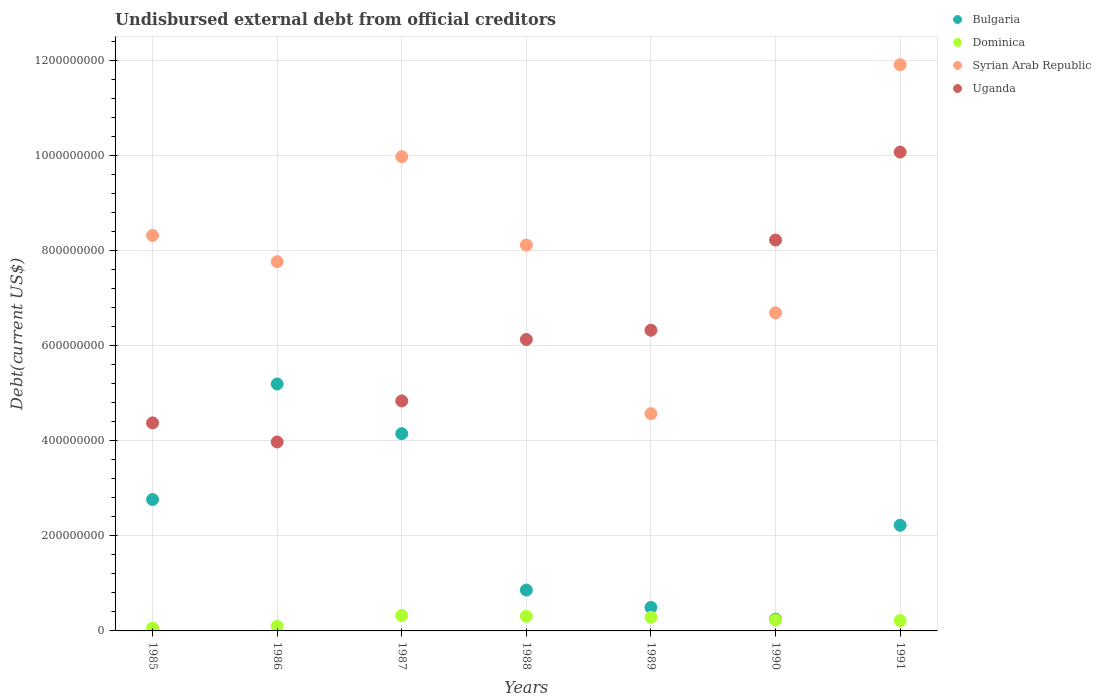What is the total debt in Syrian Arab Republic in 1987?
Your answer should be very brief. 9.97e+08. Across all years, what is the maximum total debt in Syrian Arab Republic?
Provide a succinct answer. 1.19e+09. Across all years, what is the minimum total debt in Bulgaria?
Your answer should be compact. 2.48e+07. In which year was the total debt in Uganda maximum?
Your answer should be very brief. 1991. In which year was the total debt in Bulgaria minimum?
Keep it short and to the point. 1990. What is the total total debt in Bulgaria in the graph?
Keep it short and to the point. 1.59e+09. What is the difference between the total debt in Dominica in 1985 and that in 1987?
Your answer should be compact. -2.63e+07. What is the difference between the total debt in Dominica in 1985 and the total debt in Syrian Arab Republic in 1986?
Offer a terse response. -7.70e+08. What is the average total debt in Uganda per year?
Your answer should be very brief. 6.27e+08. In the year 1985, what is the difference between the total debt in Syrian Arab Republic and total debt in Uganda?
Give a very brief answer. 3.94e+08. In how many years, is the total debt in Dominica greater than 720000000 US$?
Offer a very short reply. 0. What is the ratio of the total debt in Dominica in 1987 to that in 1990?
Your answer should be compact. 1.41. Is the total debt in Syrian Arab Republic in 1987 less than that in 1990?
Your answer should be very brief. No. What is the difference between the highest and the second highest total debt in Dominica?
Provide a succinct answer. 1.74e+06. What is the difference between the highest and the lowest total debt in Uganda?
Ensure brevity in your answer.  6.09e+08. Is the sum of the total debt in Bulgaria in 1986 and 1987 greater than the maximum total debt in Dominica across all years?
Offer a terse response. Yes. Is it the case that in every year, the sum of the total debt in Bulgaria and total debt in Syrian Arab Republic  is greater than the sum of total debt in Uganda and total debt in Dominica?
Your answer should be very brief. No. Is the total debt in Syrian Arab Republic strictly greater than the total debt in Dominica over the years?
Ensure brevity in your answer.  Yes. Is the total debt in Bulgaria strictly less than the total debt in Syrian Arab Republic over the years?
Offer a very short reply. Yes. What is the difference between two consecutive major ticks on the Y-axis?
Make the answer very short. 2.00e+08. Where does the legend appear in the graph?
Your answer should be compact. Top right. What is the title of the graph?
Keep it short and to the point. Undisbursed external debt from official creditors. Does "Brunei Darussalam" appear as one of the legend labels in the graph?
Provide a succinct answer. No. What is the label or title of the X-axis?
Your answer should be very brief. Years. What is the label or title of the Y-axis?
Your response must be concise. Debt(current US$). What is the Debt(current US$) in Bulgaria in 1985?
Your response must be concise. 2.76e+08. What is the Debt(current US$) in Dominica in 1985?
Your answer should be very brief. 6.17e+06. What is the Debt(current US$) of Syrian Arab Republic in 1985?
Offer a very short reply. 8.31e+08. What is the Debt(current US$) of Uganda in 1985?
Make the answer very short. 4.37e+08. What is the Debt(current US$) of Bulgaria in 1986?
Ensure brevity in your answer.  5.19e+08. What is the Debt(current US$) in Dominica in 1986?
Provide a succinct answer. 9.94e+06. What is the Debt(current US$) in Syrian Arab Republic in 1986?
Make the answer very short. 7.76e+08. What is the Debt(current US$) of Uganda in 1986?
Your answer should be very brief. 3.97e+08. What is the Debt(current US$) in Bulgaria in 1987?
Provide a short and direct response. 4.15e+08. What is the Debt(current US$) of Dominica in 1987?
Your answer should be compact. 3.25e+07. What is the Debt(current US$) of Syrian Arab Republic in 1987?
Keep it short and to the point. 9.97e+08. What is the Debt(current US$) in Uganda in 1987?
Keep it short and to the point. 4.83e+08. What is the Debt(current US$) in Bulgaria in 1988?
Make the answer very short. 8.59e+07. What is the Debt(current US$) in Dominica in 1988?
Offer a terse response. 3.07e+07. What is the Debt(current US$) of Syrian Arab Republic in 1988?
Give a very brief answer. 8.11e+08. What is the Debt(current US$) of Uganda in 1988?
Your answer should be compact. 6.13e+08. What is the Debt(current US$) in Bulgaria in 1989?
Ensure brevity in your answer.  4.94e+07. What is the Debt(current US$) of Dominica in 1989?
Your response must be concise. 2.86e+07. What is the Debt(current US$) of Syrian Arab Republic in 1989?
Offer a terse response. 4.57e+08. What is the Debt(current US$) of Uganda in 1989?
Keep it short and to the point. 6.32e+08. What is the Debt(current US$) of Bulgaria in 1990?
Offer a very short reply. 2.48e+07. What is the Debt(current US$) in Dominica in 1990?
Ensure brevity in your answer.  2.30e+07. What is the Debt(current US$) in Syrian Arab Republic in 1990?
Keep it short and to the point. 6.69e+08. What is the Debt(current US$) in Uganda in 1990?
Offer a very short reply. 8.22e+08. What is the Debt(current US$) in Bulgaria in 1991?
Your answer should be very brief. 2.22e+08. What is the Debt(current US$) of Dominica in 1991?
Ensure brevity in your answer.  2.18e+07. What is the Debt(current US$) in Syrian Arab Republic in 1991?
Your response must be concise. 1.19e+09. What is the Debt(current US$) in Uganda in 1991?
Make the answer very short. 1.01e+09. Across all years, what is the maximum Debt(current US$) in Bulgaria?
Keep it short and to the point. 5.19e+08. Across all years, what is the maximum Debt(current US$) in Dominica?
Your response must be concise. 3.25e+07. Across all years, what is the maximum Debt(current US$) in Syrian Arab Republic?
Your response must be concise. 1.19e+09. Across all years, what is the maximum Debt(current US$) in Uganda?
Your answer should be very brief. 1.01e+09. Across all years, what is the minimum Debt(current US$) in Bulgaria?
Provide a short and direct response. 2.48e+07. Across all years, what is the minimum Debt(current US$) of Dominica?
Your response must be concise. 6.17e+06. Across all years, what is the minimum Debt(current US$) of Syrian Arab Republic?
Make the answer very short. 4.57e+08. Across all years, what is the minimum Debt(current US$) in Uganda?
Ensure brevity in your answer.  3.97e+08. What is the total Debt(current US$) of Bulgaria in the graph?
Your answer should be compact. 1.59e+09. What is the total Debt(current US$) of Dominica in the graph?
Keep it short and to the point. 1.53e+08. What is the total Debt(current US$) in Syrian Arab Republic in the graph?
Your answer should be compact. 5.73e+09. What is the total Debt(current US$) of Uganda in the graph?
Your answer should be compact. 4.39e+09. What is the difference between the Debt(current US$) in Bulgaria in 1985 and that in 1986?
Offer a terse response. -2.43e+08. What is the difference between the Debt(current US$) in Dominica in 1985 and that in 1986?
Your answer should be compact. -3.77e+06. What is the difference between the Debt(current US$) in Syrian Arab Republic in 1985 and that in 1986?
Ensure brevity in your answer.  5.51e+07. What is the difference between the Debt(current US$) in Uganda in 1985 and that in 1986?
Give a very brief answer. 4.01e+07. What is the difference between the Debt(current US$) in Bulgaria in 1985 and that in 1987?
Make the answer very short. -1.38e+08. What is the difference between the Debt(current US$) in Dominica in 1985 and that in 1987?
Offer a terse response. -2.63e+07. What is the difference between the Debt(current US$) of Syrian Arab Republic in 1985 and that in 1987?
Keep it short and to the point. -1.66e+08. What is the difference between the Debt(current US$) of Uganda in 1985 and that in 1987?
Make the answer very short. -4.61e+07. What is the difference between the Debt(current US$) in Bulgaria in 1985 and that in 1988?
Make the answer very short. 1.90e+08. What is the difference between the Debt(current US$) in Dominica in 1985 and that in 1988?
Provide a short and direct response. -2.46e+07. What is the difference between the Debt(current US$) in Syrian Arab Republic in 1985 and that in 1988?
Ensure brevity in your answer.  2.02e+07. What is the difference between the Debt(current US$) of Uganda in 1985 and that in 1988?
Provide a short and direct response. -1.75e+08. What is the difference between the Debt(current US$) of Bulgaria in 1985 and that in 1989?
Provide a succinct answer. 2.27e+08. What is the difference between the Debt(current US$) in Dominica in 1985 and that in 1989?
Your answer should be very brief. -2.24e+07. What is the difference between the Debt(current US$) in Syrian Arab Republic in 1985 and that in 1989?
Your answer should be compact. 3.75e+08. What is the difference between the Debt(current US$) in Uganda in 1985 and that in 1989?
Your answer should be very brief. -1.95e+08. What is the difference between the Debt(current US$) in Bulgaria in 1985 and that in 1990?
Your answer should be compact. 2.51e+08. What is the difference between the Debt(current US$) in Dominica in 1985 and that in 1990?
Your answer should be very brief. -1.68e+07. What is the difference between the Debt(current US$) in Syrian Arab Republic in 1985 and that in 1990?
Offer a very short reply. 1.62e+08. What is the difference between the Debt(current US$) in Uganda in 1985 and that in 1990?
Offer a very short reply. -3.84e+08. What is the difference between the Debt(current US$) in Bulgaria in 1985 and that in 1991?
Give a very brief answer. 5.41e+07. What is the difference between the Debt(current US$) in Dominica in 1985 and that in 1991?
Your response must be concise. -1.56e+07. What is the difference between the Debt(current US$) in Syrian Arab Republic in 1985 and that in 1991?
Offer a terse response. -3.59e+08. What is the difference between the Debt(current US$) of Uganda in 1985 and that in 1991?
Your answer should be very brief. -5.69e+08. What is the difference between the Debt(current US$) of Bulgaria in 1986 and that in 1987?
Provide a succinct answer. 1.04e+08. What is the difference between the Debt(current US$) in Dominica in 1986 and that in 1987?
Ensure brevity in your answer.  -2.25e+07. What is the difference between the Debt(current US$) of Syrian Arab Republic in 1986 and that in 1987?
Offer a very short reply. -2.21e+08. What is the difference between the Debt(current US$) of Uganda in 1986 and that in 1987?
Give a very brief answer. -8.62e+07. What is the difference between the Debt(current US$) of Bulgaria in 1986 and that in 1988?
Give a very brief answer. 4.33e+08. What is the difference between the Debt(current US$) of Dominica in 1986 and that in 1988?
Offer a terse response. -2.08e+07. What is the difference between the Debt(current US$) in Syrian Arab Republic in 1986 and that in 1988?
Keep it short and to the point. -3.49e+07. What is the difference between the Debt(current US$) of Uganda in 1986 and that in 1988?
Provide a succinct answer. -2.15e+08. What is the difference between the Debt(current US$) in Bulgaria in 1986 and that in 1989?
Provide a short and direct response. 4.70e+08. What is the difference between the Debt(current US$) in Dominica in 1986 and that in 1989?
Provide a short and direct response. -1.86e+07. What is the difference between the Debt(current US$) in Syrian Arab Republic in 1986 and that in 1989?
Make the answer very short. 3.20e+08. What is the difference between the Debt(current US$) of Uganda in 1986 and that in 1989?
Give a very brief answer. -2.35e+08. What is the difference between the Debt(current US$) in Bulgaria in 1986 and that in 1990?
Offer a terse response. 4.94e+08. What is the difference between the Debt(current US$) in Dominica in 1986 and that in 1990?
Offer a very short reply. -1.30e+07. What is the difference between the Debt(current US$) in Syrian Arab Republic in 1986 and that in 1990?
Provide a short and direct response. 1.07e+08. What is the difference between the Debt(current US$) of Uganda in 1986 and that in 1990?
Ensure brevity in your answer.  -4.24e+08. What is the difference between the Debt(current US$) of Bulgaria in 1986 and that in 1991?
Give a very brief answer. 2.97e+08. What is the difference between the Debt(current US$) in Dominica in 1986 and that in 1991?
Keep it short and to the point. -1.18e+07. What is the difference between the Debt(current US$) of Syrian Arab Republic in 1986 and that in 1991?
Your response must be concise. -4.14e+08. What is the difference between the Debt(current US$) in Uganda in 1986 and that in 1991?
Provide a succinct answer. -6.09e+08. What is the difference between the Debt(current US$) in Bulgaria in 1987 and that in 1988?
Provide a succinct answer. 3.29e+08. What is the difference between the Debt(current US$) of Dominica in 1987 and that in 1988?
Make the answer very short. 1.74e+06. What is the difference between the Debt(current US$) in Syrian Arab Republic in 1987 and that in 1988?
Provide a short and direct response. 1.86e+08. What is the difference between the Debt(current US$) of Uganda in 1987 and that in 1988?
Keep it short and to the point. -1.29e+08. What is the difference between the Debt(current US$) of Bulgaria in 1987 and that in 1989?
Make the answer very short. 3.65e+08. What is the difference between the Debt(current US$) of Dominica in 1987 and that in 1989?
Provide a succinct answer. 3.93e+06. What is the difference between the Debt(current US$) in Syrian Arab Republic in 1987 and that in 1989?
Provide a succinct answer. 5.40e+08. What is the difference between the Debt(current US$) of Uganda in 1987 and that in 1989?
Your response must be concise. -1.49e+08. What is the difference between the Debt(current US$) in Bulgaria in 1987 and that in 1990?
Your response must be concise. 3.90e+08. What is the difference between the Debt(current US$) of Dominica in 1987 and that in 1990?
Keep it short and to the point. 9.52e+06. What is the difference between the Debt(current US$) in Syrian Arab Republic in 1987 and that in 1990?
Give a very brief answer. 3.28e+08. What is the difference between the Debt(current US$) in Uganda in 1987 and that in 1990?
Keep it short and to the point. -3.38e+08. What is the difference between the Debt(current US$) in Bulgaria in 1987 and that in 1991?
Provide a succinct answer. 1.93e+08. What is the difference between the Debt(current US$) in Dominica in 1987 and that in 1991?
Make the answer very short. 1.07e+07. What is the difference between the Debt(current US$) in Syrian Arab Republic in 1987 and that in 1991?
Keep it short and to the point. -1.93e+08. What is the difference between the Debt(current US$) of Uganda in 1987 and that in 1991?
Make the answer very short. -5.23e+08. What is the difference between the Debt(current US$) of Bulgaria in 1988 and that in 1989?
Ensure brevity in your answer.  3.65e+07. What is the difference between the Debt(current US$) of Dominica in 1988 and that in 1989?
Offer a very short reply. 2.19e+06. What is the difference between the Debt(current US$) in Syrian Arab Republic in 1988 and that in 1989?
Your answer should be compact. 3.54e+08. What is the difference between the Debt(current US$) of Uganda in 1988 and that in 1989?
Your answer should be very brief. -1.95e+07. What is the difference between the Debt(current US$) of Bulgaria in 1988 and that in 1990?
Your answer should be compact. 6.12e+07. What is the difference between the Debt(current US$) in Dominica in 1988 and that in 1990?
Make the answer very short. 7.78e+06. What is the difference between the Debt(current US$) of Syrian Arab Republic in 1988 and that in 1990?
Give a very brief answer. 1.42e+08. What is the difference between the Debt(current US$) of Uganda in 1988 and that in 1990?
Your answer should be compact. -2.09e+08. What is the difference between the Debt(current US$) in Bulgaria in 1988 and that in 1991?
Provide a succinct answer. -1.36e+08. What is the difference between the Debt(current US$) of Dominica in 1988 and that in 1991?
Your answer should be very brief. 8.97e+06. What is the difference between the Debt(current US$) in Syrian Arab Republic in 1988 and that in 1991?
Provide a short and direct response. -3.79e+08. What is the difference between the Debt(current US$) in Uganda in 1988 and that in 1991?
Offer a terse response. -3.94e+08. What is the difference between the Debt(current US$) of Bulgaria in 1989 and that in 1990?
Make the answer very short. 2.47e+07. What is the difference between the Debt(current US$) in Dominica in 1989 and that in 1990?
Your response must be concise. 5.59e+06. What is the difference between the Debt(current US$) of Syrian Arab Republic in 1989 and that in 1990?
Your answer should be very brief. -2.12e+08. What is the difference between the Debt(current US$) in Uganda in 1989 and that in 1990?
Your answer should be compact. -1.90e+08. What is the difference between the Debt(current US$) in Bulgaria in 1989 and that in 1991?
Provide a succinct answer. -1.73e+08. What is the difference between the Debt(current US$) in Dominica in 1989 and that in 1991?
Your answer should be very brief. 6.78e+06. What is the difference between the Debt(current US$) of Syrian Arab Republic in 1989 and that in 1991?
Offer a very short reply. -7.34e+08. What is the difference between the Debt(current US$) in Uganda in 1989 and that in 1991?
Your answer should be very brief. -3.75e+08. What is the difference between the Debt(current US$) of Bulgaria in 1990 and that in 1991?
Keep it short and to the point. -1.97e+08. What is the difference between the Debt(current US$) of Dominica in 1990 and that in 1991?
Provide a short and direct response. 1.19e+06. What is the difference between the Debt(current US$) in Syrian Arab Republic in 1990 and that in 1991?
Ensure brevity in your answer.  -5.21e+08. What is the difference between the Debt(current US$) in Uganda in 1990 and that in 1991?
Offer a terse response. -1.85e+08. What is the difference between the Debt(current US$) of Bulgaria in 1985 and the Debt(current US$) of Dominica in 1986?
Make the answer very short. 2.66e+08. What is the difference between the Debt(current US$) of Bulgaria in 1985 and the Debt(current US$) of Syrian Arab Republic in 1986?
Give a very brief answer. -5.00e+08. What is the difference between the Debt(current US$) of Bulgaria in 1985 and the Debt(current US$) of Uganda in 1986?
Ensure brevity in your answer.  -1.21e+08. What is the difference between the Debt(current US$) in Dominica in 1985 and the Debt(current US$) in Syrian Arab Republic in 1986?
Your answer should be very brief. -7.70e+08. What is the difference between the Debt(current US$) in Dominica in 1985 and the Debt(current US$) in Uganda in 1986?
Your answer should be very brief. -3.91e+08. What is the difference between the Debt(current US$) of Syrian Arab Republic in 1985 and the Debt(current US$) of Uganda in 1986?
Provide a short and direct response. 4.34e+08. What is the difference between the Debt(current US$) of Bulgaria in 1985 and the Debt(current US$) of Dominica in 1987?
Give a very brief answer. 2.44e+08. What is the difference between the Debt(current US$) of Bulgaria in 1985 and the Debt(current US$) of Syrian Arab Republic in 1987?
Your response must be concise. -7.21e+08. What is the difference between the Debt(current US$) in Bulgaria in 1985 and the Debt(current US$) in Uganda in 1987?
Provide a short and direct response. -2.07e+08. What is the difference between the Debt(current US$) in Dominica in 1985 and the Debt(current US$) in Syrian Arab Republic in 1987?
Ensure brevity in your answer.  -9.91e+08. What is the difference between the Debt(current US$) in Dominica in 1985 and the Debt(current US$) in Uganda in 1987?
Provide a succinct answer. -4.77e+08. What is the difference between the Debt(current US$) in Syrian Arab Republic in 1985 and the Debt(current US$) in Uganda in 1987?
Provide a short and direct response. 3.48e+08. What is the difference between the Debt(current US$) of Bulgaria in 1985 and the Debt(current US$) of Dominica in 1988?
Give a very brief answer. 2.45e+08. What is the difference between the Debt(current US$) in Bulgaria in 1985 and the Debt(current US$) in Syrian Arab Republic in 1988?
Your response must be concise. -5.35e+08. What is the difference between the Debt(current US$) of Bulgaria in 1985 and the Debt(current US$) of Uganda in 1988?
Provide a succinct answer. -3.36e+08. What is the difference between the Debt(current US$) of Dominica in 1985 and the Debt(current US$) of Syrian Arab Republic in 1988?
Offer a very short reply. -8.05e+08. What is the difference between the Debt(current US$) in Dominica in 1985 and the Debt(current US$) in Uganda in 1988?
Make the answer very short. -6.06e+08. What is the difference between the Debt(current US$) in Syrian Arab Republic in 1985 and the Debt(current US$) in Uganda in 1988?
Provide a short and direct response. 2.19e+08. What is the difference between the Debt(current US$) in Bulgaria in 1985 and the Debt(current US$) in Dominica in 1989?
Your answer should be compact. 2.48e+08. What is the difference between the Debt(current US$) in Bulgaria in 1985 and the Debt(current US$) in Syrian Arab Republic in 1989?
Offer a terse response. -1.80e+08. What is the difference between the Debt(current US$) in Bulgaria in 1985 and the Debt(current US$) in Uganda in 1989?
Your response must be concise. -3.56e+08. What is the difference between the Debt(current US$) of Dominica in 1985 and the Debt(current US$) of Syrian Arab Republic in 1989?
Provide a succinct answer. -4.51e+08. What is the difference between the Debt(current US$) in Dominica in 1985 and the Debt(current US$) in Uganda in 1989?
Make the answer very short. -6.26e+08. What is the difference between the Debt(current US$) in Syrian Arab Republic in 1985 and the Debt(current US$) in Uganda in 1989?
Offer a very short reply. 1.99e+08. What is the difference between the Debt(current US$) in Bulgaria in 1985 and the Debt(current US$) in Dominica in 1990?
Give a very brief answer. 2.53e+08. What is the difference between the Debt(current US$) in Bulgaria in 1985 and the Debt(current US$) in Syrian Arab Republic in 1990?
Offer a terse response. -3.93e+08. What is the difference between the Debt(current US$) of Bulgaria in 1985 and the Debt(current US$) of Uganda in 1990?
Give a very brief answer. -5.46e+08. What is the difference between the Debt(current US$) in Dominica in 1985 and the Debt(current US$) in Syrian Arab Republic in 1990?
Your answer should be very brief. -6.63e+08. What is the difference between the Debt(current US$) of Dominica in 1985 and the Debt(current US$) of Uganda in 1990?
Offer a very short reply. -8.16e+08. What is the difference between the Debt(current US$) in Syrian Arab Republic in 1985 and the Debt(current US$) in Uganda in 1990?
Ensure brevity in your answer.  9.60e+06. What is the difference between the Debt(current US$) in Bulgaria in 1985 and the Debt(current US$) in Dominica in 1991?
Provide a short and direct response. 2.54e+08. What is the difference between the Debt(current US$) in Bulgaria in 1985 and the Debt(current US$) in Syrian Arab Republic in 1991?
Provide a short and direct response. -9.14e+08. What is the difference between the Debt(current US$) in Bulgaria in 1985 and the Debt(current US$) in Uganda in 1991?
Make the answer very short. -7.30e+08. What is the difference between the Debt(current US$) in Dominica in 1985 and the Debt(current US$) in Syrian Arab Republic in 1991?
Your answer should be compact. -1.18e+09. What is the difference between the Debt(current US$) of Dominica in 1985 and the Debt(current US$) of Uganda in 1991?
Give a very brief answer. -1.00e+09. What is the difference between the Debt(current US$) of Syrian Arab Republic in 1985 and the Debt(current US$) of Uganda in 1991?
Offer a very short reply. -1.75e+08. What is the difference between the Debt(current US$) in Bulgaria in 1986 and the Debt(current US$) in Dominica in 1987?
Your answer should be compact. 4.87e+08. What is the difference between the Debt(current US$) of Bulgaria in 1986 and the Debt(current US$) of Syrian Arab Republic in 1987?
Offer a terse response. -4.78e+08. What is the difference between the Debt(current US$) in Bulgaria in 1986 and the Debt(current US$) in Uganda in 1987?
Provide a short and direct response. 3.57e+07. What is the difference between the Debt(current US$) of Dominica in 1986 and the Debt(current US$) of Syrian Arab Republic in 1987?
Your response must be concise. -9.87e+08. What is the difference between the Debt(current US$) in Dominica in 1986 and the Debt(current US$) in Uganda in 1987?
Provide a short and direct response. -4.74e+08. What is the difference between the Debt(current US$) in Syrian Arab Republic in 1986 and the Debt(current US$) in Uganda in 1987?
Provide a short and direct response. 2.93e+08. What is the difference between the Debt(current US$) of Bulgaria in 1986 and the Debt(current US$) of Dominica in 1988?
Give a very brief answer. 4.88e+08. What is the difference between the Debt(current US$) of Bulgaria in 1986 and the Debt(current US$) of Syrian Arab Republic in 1988?
Your response must be concise. -2.92e+08. What is the difference between the Debt(current US$) of Bulgaria in 1986 and the Debt(current US$) of Uganda in 1988?
Keep it short and to the point. -9.35e+07. What is the difference between the Debt(current US$) in Dominica in 1986 and the Debt(current US$) in Syrian Arab Republic in 1988?
Offer a very short reply. -8.01e+08. What is the difference between the Debt(current US$) in Dominica in 1986 and the Debt(current US$) in Uganda in 1988?
Offer a very short reply. -6.03e+08. What is the difference between the Debt(current US$) in Syrian Arab Republic in 1986 and the Debt(current US$) in Uganda in 1988?
Provide a succinct answer. 1.64e+08. What is the difference between the Debt(current US$) of Bulgaria in 1986 and the Debt(current US$) of Dominica in 1989?
Your response must be concise. 4.91e+08. What is the difference between the Debt(current US$) in Bulgaria in 1986 and the Debt(current US$) in Syrian Arab Republic in 1989?
Your answer should be very brief. 6.24e+07. What is the difference between the Debt(current US$) in Bulgaria in 1986 and the Debt(current US$) in Uganda in 1989?
Offer a terse response. -1.13e+08. What is the difference between the Debt(current US$) in Dominica in 1986 and the Debt(current US$) in Syrian Arab Republic in 1989?
Offer a terse response. -4.47e+08. What is the difference between the Debt(current US$) of Dominica in 1986 and the Debt(current US$) of Uganda in 1989?
Keep it short and to the point. -6.22e+08. What is the difference between the Debt(current US$) of Syrian Arab Republic in 1986 and the Debt(current US$) of Uganda in 1989?
Your answer should be compact. 1.44e+08. What is the difference between the Debt(current US$) of Bulgaria in 1986 and the Debt(current US$) of Dominica in 1990?
Ensure brevity in your answer.  4.96e+08. What is the difference between the Debt(current US$) of Bulgaria in 1986 and the Debt(current US$) of Syrian Arab Republic in 1990?
Offer a very short reply. -1.50e+08. What is the difference between the Debt(current US$) of Bulgaria in 1986 and the Debt(current US$) of Uganda in 1990?
Keep it short and to the point. -3.03e+08. What is the difference between the Debt(current US$) in Dominica in 1986 and the Debt(current US$) in Syrian Arab Republic in 1990?
Provide a succinct answer. -6.59e+08. What is the difference between the Debt(current US$) of Dominica in 1986 and the Debt(current US$) of Uganda in 1990?
Offer a very short reply. -8.12e+08. What is the difference between the Debt(current US$) of Syrian Arab Republic in 1986 and the Debt(current US$) of Uganda in 1990?
Make the answer very short. -4.55e+07. What is the difference between the Debt(current US$) of Bulgaria in 1986 and the Debt(current US$) of Dominica in 1991?
Ensure brevity in your answer.  4.97e+08. What is the difference between the Debt(current US$) in Bulgaria in 1986 and the Debt(current US$) in Syrian Arab Republic in 1991?
Offer a very short reply. -6.71e+08. What is the difference between the Debt(current US$) of Bulgaria in 1986 and the Debt(current US$) of Uganda in 1991?
Provide a short and direct response. -4.88e+08. What is the difference between the Debt(current US$) in Dominica in 1986 and the Debt(current US$) in Syrian Arab Republic in 1991?
Your response must be concise. -1.18e+09. What is the difference between the Debt(current US$) in Dominica in 1986 and the Debt(current US$) in Uganda in 1991?
Provide a succinct answer. -9.97e+08. What is the difference between the Debt(current US$) in Syrian Arab Republic in 1986 and the Debt(current US$) in Uganda in 1991?
Provide a short and direct response. -2.30e+08. What is the difference between the Debt(current US$) in Bulgaria in 1987 and the Debt(current US$) in Dominica in 1988?
Your answer should be very brief. 3.84e+08. What is the difference between the Debt(current US$) of Bulgaria in 1987 and the Debt(current US$) of Syrian Arab Republic in 1988?
Your answer should be compact. -3.96e+08. What is the difference between the Debt(current US$) of Bulgaria in 1987 and the Debt(current US$) of Uganda in 1988?
Give a very brief answer. -1.98e+08. What is the difference between the Debt(current US$) of Dominica in 1987 and the Debt(current US$) of Syrian Arab Republic in 1988?
Provide a succinct answer. -7.79e+08. What is the difference between the Debt(current US$) in Dominica in 1987 and the Debt(current US$) in Uganda in 1988?
Your response must be concise. -5.80e+08. What is the difference between the Debt(current US$) of Syrian Arab Republic in 1987 and the Debt(current US$) of Uganda in 1988?
Offer a terse response. 3.84e+08. What is the difference between the Debt(current US$) in Bulgaria in 1987 and the Debt(current US$) in Dominica in 1989?
Keep it short and to the point. 3.86e+08. What is the difference between the Debt(current US$) of Bulgaria in 1987 and the Debt(current US$) of Syrian Arab Republic in 1989?
Offer a very short reply. -4.20e+07. What is the difference between the Debt(current US$) in Bulgaria in 1987 and the Debt(current US$) in Uganda in 1989?
Ensure brevity in your answer.  -2.17e+08. What is the difference between the Debt(current US$) in Dominica in 1987 and the Debt(current US$) in Syrian Arab Republic in 1989?
Your response must be concise. -4.24e+08. What is the difference between the Debt(current US$) of Dominica in 1987 and the Debt(current US$) of Uganda in 1989?
Your response must be concise. -6.00e+08. What is the difference between the Debt(current US$) in Syrian Arab Republic in 1987 and the Debt(current US$) in Uganda in 1989?
Offer a terse response. 3.65e+08. What is the difference between the Debt(current US$) in Bulgaria in 1987 and the Debt(current US$) in Dominica in 1990?
Provide a succinct answer. 3.92e+08. What is the difference between the Debt(current US$) in Bulgaria in 1987 and the Debt(current US$) in Syrian Arab Republic in 1990?
Ensure brevity in your answer.  -2.54e+08. What is the difference between the Debt(current US$) in Bulgaria in 1987 and the Debt(current US$) in Uganda in 1990?
Your answer should be very brief. -4.07e+08. What is the difference between the Debt(current US$) of Dominica in 1987 and the Debt(current US$) of Syrian Arab Republic in 1990?
Offer a terse response. -6.36e+08. What is the difference between the Debt(current US$) of Dominica in 1987 and the Debt(current US$) of Uganda in 1990?
Your response must be concise. -7.89e+08. What is the difference between the Debt(current US$) in Syrian Arab Republic in 1987 and the Debt(current US$) in Uganda in 1990?
Give a very brief answer. 1.75e+08. What is the difference between the Debt(current US$) in Bulgaria in 1987 and the Debt(current US$) in Dominica in 1991?
Make the answer very short. 3.93e+08. What is the difference between the Debt(current US$) of Bulgaria in 1987 and the Debt(current US$) of Syrian Arab Republic in 1991?
Keep it short and to the point. -7.76e+08. What is the difference between the Debt(current US$) of Bulgaria in 1987 and the Debt(current US$) of Uganda in 1991?
Provide a succinct answer. -5.92e+08. What is the difference between the Debt(current US$) in Dominica in 1987 and the Debt(current US$) in Syrian Arab Republic in 1991?
Offer a terse response. -1.16e+09. What is the difference between the Debt(current US$) of Dominica in 1987 and the Debt(current US$) of Uganda in 1991?
Your response must be concise. -9.74e+08. What is the difference between the Debt(current US$) of Syrian Arab Republic in 1987 and the Debt(current US$) of Uganda in 1991?
Ensure brevity in your answer.  -9.66e+06. What is the difference between the Debt(current US$) in Bulgaria in 1988 and the Debt(current US$) in Dominica in 1989?
Your answer should be compact. 5.74e+07. What is the difference between the Debt(current US$) of Bulgaria in 1988 and the Debt(current US$) of Syrian Arab Republic in 1989?
Your response must be concise. -3.71e+08. What is the difference between the Debt(current US$) of Bulgaria in 1988 and the Debt(current US$) of Uganda in 1989?
Make the answer very short. -5.46e+08. What is the difference between the Debt(current US$) in Dominica in 1988 and the Debt(current US$) in Syrian Arab Republic in 1989?
Give a very brief answer. -4.26e+08. What is the difference between the Debt(current US$) of Dominica in 1988 and the Debt(current US$) of Uganda in 1989?
Offer a very short reply. -6.01e+08. What is the difference between the Debt(current US$) in Syrian Arab Republic in 1988 and the Debt(current US$) in Uganda in 1989?
Provide a succinct answer. 1.79e+08. What is the difference between the Debt(current US$) in Bulgaria in 1988 and the Debt(current US$) in Dominica in 1990?
Your answer should be compact. 6.30e+07. What is the difference between the Debt(current US$) in Bulgaria in 1988 and the Debt(current US$) in Syrian Arab Republic in 1990?
Give a very brief answer. -5.83e+08. What is the difference between the Debt(current US$) of Bulgaria in 1988 and the Debt(current US$) of Uganda in 1990?
Your answer should be very brief. -7.36e+08. What is the difference between the Debt(current US$) in Dominica in 1988 and the Debt(current US$) in Syrian Arab Republic in 1990?
Ensure brevity in your answer.  -6.38e+08. What is the difference between the Debt(current US$) of Dominica in 1988 and the Debt(current US$) of Uganda in 1990?
Your response must be concise. -7.91e+08. What is the difference between the Debt(current US$) of Syrian Arab Republic in 1988 and the Debt(current US$) of Uganda in 1990?
Your answer should be compact. -1.06e+07. What is the difference between the Debt(current US$) in Bulgaria in 1988 and the Debt(current US$) in Dominica in 1991?
Your answer should be compact. 6.42e+07. What is the difference between the Debt(current US$) in Bulgaria in 1988 and the Debt(current US$) in Syrian Arab Republic in 1991?
Ensure brevity in your answer.  -1.10e+09. What is the difference between the Debt(current US$) in Bulgaria in 1988 and the Debt(current US$) in Uganda in 1991?
Provide a short and direct response. -9.21e+08. What is the difference between the Debt(current US$) of Dominica in 1988 and the Debt(current US$) of Syrian Arab Republic in 1991?
Give a very brief answer. -1.16e+09. What is the difference between the Debt(current US$) in Dominica in 1988 and the Debt(current US$) in Uganda in 1991?
Make the answer very short. -9.76e+08. What is the difference between the Debt(current US$) of Syrian Arab Republic in 1988 and the Debt(current US$) of Uganda in 1991?
Offer a terse response. -1.95e+08. What is the difference between the Debt(current US$) in Bulgaria in 1989 and the Debt(current US$) in Dominica in 1990?
Give a very brief answer. 2.64e+07. What is the difference between the Debt(current US$) in Bulgaria in 1989 and the Debt(current US$) in Syrian Arab Republic in 1990?
Provide a succinct answer. -6.19e+08. What is the difference between the Debt(current US$) in Bulgaria in 1989 and the Debt(current US$) in Uganda in 1990?
Give a very brief answer. -7.72e+08. What is the difference between the Debt(current US$) in Dominica in 1989 and the Debt(current US$) in Syrian Arab Republic in 1990?
Make the answer very short. -6.40e+08. What is the difference between the Debt(current US$) of Dominica in 1989 and the Debt(current US$) of Uganda in 1990?
Provide a succinct answer. -7.93e+08. What is the difference between the Debt(current US$) in Syrian Arab Republic in 1989 and the Debt(current US$) in Uganda in 1990?
Offer a terse response. -3.65e+08. What is the difference between the Debt(current US$) of Bulgaria in 1989 and the Debt(current US$) of Dominica in 1991?
Your answer should be very brief. 2.76e+07. What is the difference between the Debt(current US$) of Bulgaria in 1989 and the Debt(current US$) of Syrian Arab Republic in 1991?
Your response must be concise. -1.14e+09. What is the difference between the Debt(current US$) of Bulgaria in 1989 and the Debt(current US$) of Uganda in 1991?
Your response must be concise. -9.57e+08. What is the difference between the Debt(current US$) in Dominica in 1989 and the Debt(current US$) in Syrian Arab Republic in 1991?
Provide a succinct answer. -1.16e+09. What is the difference between the Debt(current US$) in Dominica in 1989 and the Debt(current US$) in Uganda in 1991?
Keep it short and to the point. -9.78e+08. What is the difference between the Debt(current US$) of Syrian Arab Republic in 1989 and the Debt(current US$) of Uganda in 1991?
Keep it short and to the point. -5.50e+08. What is the difference between the Debt(current US$) of Bulgaria in 1990 and the Debt(current US$) of Dominica in 1991?
Offer a terse response. 2.97e+06. What is the difference between the Debt(current US$) of Bulgaria in 1990 and the Debt(current US$) of Syrian Arab Republic in 1991?
Keep it short and to the point. -1.17e+09. What is the difference between the Debt(current US$) in Bulgaria in 1990 and the Debt(current US$) in Uganda in 1991?
Your response must be concise. -9.82e+08. What is the difference between the Debt(current US$) in Dominica in 1990 and the Debt(current US$) in Syrian Arab Republic in 1991?
Ensure brevity in your answer.  -1.17e+09. What is the difference between the Debt(current US$) in Dominica in 1990 and the Debt(current US$) in Uganda in 1991?
Give a very brief answer. -9.84e+08. What is the difference between the Debt(current US$) in Syrian Arab Republic in 1990 and the Debt(current US$) in Uganda in 1991?
Your answer should be very brief. -3.38e+08. What is the average Debt(current US$) of Bulgaria per year?
Ensure brevity in your answer.  2.27e+08. What is the average Debt(current US$) of Dominica per year?
Your answer should be compact. 2.18e+07. What is the average Debt(current US$) in Syrian Arab Republic per year?
Your answer should be compact. 8.19e+08. What is the average Debt(current US$) in Uganda per year?
Provide a short and direct response. 6.27e+08. In the year 1985, what is the difference between the Debt(current US$) in Bulgaria and Debt(current US$) in Dominica?
Keep it short and to the point. 2.70e+08. In the year 1985, what is the difference between the Debt(current US$) of Bulgaria and Debt(current US$) of Syrian Arab Republic?
Provide a succinct answer. -5.55e+08. In the year 1985, what is the difference between the Debt(current US$) of Bulgaria and Debt(current US$) of Uganda?
Offer a terse response. -1.61e+08. In the year 1985, what is the difference between the Debt(current US$) in Dominica and Debt(current US$) in Syrian Arab Republic?
Your answer should be very brief. -8.25e+08. In the year 1985, what is the difference between the Debt(current US$) of Dominica and Debt(current US$) of Uganda?
Your answer should be compact. -4.31e+08. In the year 1985, what is the difference between the Debt(current US$) of Syrian Arab Republic and Debt(current US$) of Uganda?
Your answer should be very brief. 3.94e+08. In the year 1986, what is the difference between the Debt(current US$) in Bulgaria and Debt(current US$) in Dominica?
Offer a very short reply. 5.09e+08. In the year 1986, what is the difference between the Debt(current US$) of Bulgaria and Debt(current US$) of Syrian Arab Republic?
Offer a very short reply. -2.57e+08. In the year 1986, what is the difference between the Debt(current US$) of Bulgaria and Debt(current US$) of Uganda?
Your answer should be compact. 1.22e+08. In the year 1986, what is the difference between the Debt(current US$) of Dominica and Debt(current US$) of Syrian Arab Republic?
Keep it short and to the point. -7.66e+08. In the year 1986, what is the difference between the Debt(current US$) of Dominica and Debt(current US$) of Uganda?
Offer a very short reply. -3.87e+08. In the year 1986, what is the difference between the Debt(current US$) of Syrian Arab Republic and Debt(current US$) of Uganda?
Offer a terse response. 3.79e+08. In the year 1987, what is the difference between the Debt(current US$) in Bulgaria and Debt(current US$) in Dominica?
Give a very brief answer. 3.82e+08. In the year 1987, what is the difference between the Debt(current US$) in Bulgaria and Debt(current US$) in Syrian Arab Republic?
Provide a short and direct response. -5.82e+08. In the year 1987, what is the difference between the Debt(current US$) of Bulgaria and Debt(current US$) of Uganda?
Your answer should be very brief. -6.87e+07. In the year 1987, what is the difference between the Debt(current US$) of Dominica and Debt(current US$) of Syrian Arab Republic?
Give a very brief answer. -9.65e+08. In the year 1987, what is the difference between the Debt(current US$) of Dominica and Debt(current US$) of Uganda?
Your response must be concise. -4.51e+08. In the year 1987, what is the difference between the Debt(current US$) of Syrian Arab Republic and Debt(current US$) of Uganda?
Your answer should be very brief. 5.14e+08. In the year 1988, what is the difference between the Debt(current US$) in Bulgaria and Debt(current US$) in Dominica?
Keep it short and to the point. 5.52e+07. In the year 1988, what is the difference between the Debt(current US$) of Bulgaria and Debt(current US$) of Syrian Arab Republic?
Provide a short and direct response. -7.25e+08. In the year 1988, what is the difference between the Debt(current US$) in Bulgaria and Debt(current US$) in Uganda?
Ensure brevity in your answer.  -5.27e+08. In the year 1988, what is the difference between the Debt(current US$) of Dominica and Debt(current US$) of Syrian Arab Republic?
Your answer should be very brief. -7.80e+08. In the year 1988, what is the difference between the Debt(current US$) of Dominica and Debt(current US$) of Uganda?
Provide a succinct answer. -5.82e+08. In the year 1988, what is the difference between the Debt(current US$) of Syrian Arab Republic and Debt(current US$) of Uganda?
Make the answer very short. 1.99e+08. In the year 1989, what is the difference between the Debt(current US$) in Bulgaria and Debt(current US$) in Dominica?
Offer a very short reply. 2.08e+07. In the year 1989, what is the difference between the Debt(current US$) in Bulgaria and Debt(current US$) in Syrian Arab Republic?
Give a very brief answer. -4.07e+08. In the year 1989, what is the difference between the Debt(current US$) of Bulgaria and Debt(current US$) of Uganda?
Ensure brevity in your answer.  -5.83e+08. In the year 1989, what is the difference between the Debt(current US$) in Dominica and Debt(current US$) in Syrian Arab Republic?
Give a very brief answer. -4.28e+08. In the year 1989, what is the difference between the Debt(current US$) of Dominica and Debt(current US$) of Uganda?
Make the answer very short. -6.04e+08. In the year 1989, what is the difference between the Debt(current US$) in Syrian Arab Republic and Debt(current US$) in Uganda?
Provide a short and direct response. -1.75e+08. In the year 1990, what is the difference between the Debt(current US$) of Bulgaria and Debt(current US$) of Dominica?
Ensure brevity in your answer.  1.78e+06. In the year 1990, what is the difference between the Debt(current US$) in Bulgaria and Debt(current US$) in Syrian Arab Republic?
Give a very brief answer. -6.44e+08. In the year 1990, what is the difference between the Debt(current US$) of Bulgaria and Debt(current US$) of Uganda?
Provide a succinct answer. -7.97e+08. In the year 1990, what is the difference between the Debt(current US$) in Dominica and Debt(current US$) in Syrian Arab Republic?
Keep it short and to the point. -6.46e+08. In the year 1990, what is the difference between the Debt(current US$) in Dominica and Debt(current US$) in Uganda?
Provide a short and direct response. -7.99e+08. In the year 1990, what is the difference between the Debt(current US$) in Syrian Arab Republic and Debt(current US$) in Uganda?
Offer a very short reply. -1.53e+08. In the year 1991, what is the difference between the Debt(current US$) in Bulgaria and Debt(current US$) in Dominica?
Offer a terse response. 2.00e+08. In the year 1991, what is the difference between the Debt(current US$) of Bulgaria and Debt(current US$) of Syrian Arab Republic?
Give a very brief answer. -9.68e+08. In the year 1991, what is the difference between the Debt(current US$) of Bulgaria and Debt(current US$) of Uganda?
Ensure brevity in your answer.  -7.85e+08. In the year 1991, what is the difference between the Debt(current US$) of Dominica and Debt(current US$) of Syrian Arab Republic?
Offer a very short reply. -1.17e+09. In the year 1991, what is the difference between the Debt(current US$) of Dominica and Debt(current US$) of Uganda?
Your answer should be very brief. -9.85e+08. In the year 1991, what is the difference between the Debt(current US$) in Syrian Arab Republic and Debt(current US$) in Uganda?
Offer a terse response. 1.84e+08. What is the ratio of the Debt(current US$) in Bulgaria in 1985 to that in 1986?
Your answer should be very brief. 0.53. What is the ratio of the Debt(current US$) of Dominica in 1985 to that in 1986?
Your response must be concise. 0.62. What is the ratio of the Debt(current US$) of Syrian Arab Republic in 1985 to that in 1986?
Ensure brevity in your answer.  1.07. What is the ratio of the Debt(current US$) in Uganda in 1985 to that in 1986?
Your answer should be compact. 1.1. What is the ratio of the Debt(current US$) in Bulgaria in 1985 to that in 1987?
Provide a short and direct response. 0.67. What is the ratio of the Debt(current US$) of Dominica in 1985 to that in 1987?
Ensure brevity in your answer.  0.19. What is the ratio of the Debt(current US$) in Syrian Arab Republic in 1985 to that in 1987?
Offer a terse response. 0.83. What is the ratio of the Debt(current US$) of Uganda in 1985 to that in 1987?
Your answer should be very brief. 0.9. What is the ratio of the Debt(current US$) in Bulgaria in 1985 to that in 1988?
Offer a very short reply. 3.21. What is the ratio of the Debt(current US$) in Dominica in 1985 to that in 1988?
Your answer should be very brief. 0.2. What is the ratio of the Debt(current US$) in Syrian Arab Republic in 1985 to that in 1988?
Provide a succinct answer. 1.02. What is the ratio of the Debt(current US$) of Uganda in 1985 to that in 1988?
Ensure brevity in your answer.  0.71. What is the ratio of the Debt(current US$) in Bulgaria in 1985 to that in 1989?
Ensure brevity in your answer.  5.59. What is the ratio of the Debt(current US$) of Dominica in 1985 to that in 1989?
Offer a terse response. 0.22. What is the ratio of the Debt(current US$) of Syrian Arab Republic in 1985 to that in 1989?
Offer a terse response. 1.82. What is the ratio of the Debt(current US$) in Uganda in 1985 to that in 1989?
Provide a short and direct response. 0.69. What is the ratio of the Debt(current US$) of Bulgaria in 1985 to that in 1990?
Make the answer very short. 11.16. What is the ratio of the Debt(current US$) of Dominica in 1985 to that in 1990?
Ensure brevity in your answer.  0.27. What is the ratio of the Debt(current US$) in Syrian Arab Republic in 1985 to that in 1990?
Your response must be concise. 1.24. What is the ratio of the Debt(current US$) in Uganda in 1985 to that in 1990?
Ensure brevity in your answer.  0.53. What is the ratio of the Debt(current US$) of Bulgaria in 1985 to that in 1991?
Your answer should be very brief. 1.24. What is the ratio of the Debt(current US$) of Dominica in 1985 to that in 1991?
Provide a succinct answer. 0.28. What is the ratio of the Debt(current US$) in Syrian Arab Republic in 1985 to that in 1991?
Give a very brief answer. 0.7. What is the ratio of the Debt(current US$) of Uganda in 1985 to that in 1991?
Make the answer very short. 0.43. What is the ratio of the Debt(current US$) in Bulgaria in 1986 to that in 1987?
Provide a succinct answer. 1.25. What is the ratio of the Debt(current US$) in Dominica in 1986 to that in 1987?
Your answer should be compact. 0.31. What is the ratio of the Debt(current US$) of Syrian Arab Republic in 1986 to that in 1987?
Make the answer very short. 0.78. What is the ratio of the Debt(current US$) in Uganda in 1986 to that in 1987?
Offer a terse response. 0.82. What is the ratio of the Debt(current US$) in Bulgaria in 1986 to that in 1988?
Offer a terse response. 6.04. What is the ratio of the Debt(current US$) of Dominica in 1986 to that in 1988?
Give a very brief answer. 0.32. What is the ratio of the Debt(current US$) of Syrian Arab Republic in 1986 to that in 1988?
Provide a short and direct response. 0.96. What is the ratio of the Debt(current US$) in Uganda in 1986 to that in 1988?
Keep it short and to the point. 0.65. What is the ratio of the Debt(current US$) in Bulgaria in 1986 to that in 1989?
Make the answer very short. 10.51. What is the ratio of the Debt(current US$) in Dominica in 1986 to that in 1989?
Ensure brevity in your answer.  0.35. What is the ratio of the Debt(current US$) in Syrian Arab Republic in 1986 to that in 1989?
Offer a very short reply. 1.7. What is the ratio of the Debt(current US$) in Uganda in 1986 to that in 1989?
Ensure brevity in your answer.  0.63. What is the ratio of the Debt(current US$) in Bulgaria in 1986 to that in 1990?
Your answer should be compact. 20.97. What is the ratio of the Debt(current US$) in Dominica in 1986 to that in 1990?
Give a very brief answer. 0.43. What is the ratio of the Debt(current US$) in Syrian Arab Republic in 1986 to that in 1990?
Provide a short and direct response. 1.16. What is the ratio of the Debt(current US$) in Uganda in 1986 to that in 1990?
Provide a succinct answer. 0.48. What is the ratio of the Debt(current US$) of Bulgaria in 1986 to that in 1991?
Your answer should be compact. 2.34. What is the ratio of the Debt(current US$) of Dominica in 1986 to that in 1991?
Keep it short and to the point. 0.46. What is the ratio of the Debt(current US$) in Syrian Arab Republic in 1986 to that in 1991?
Your response must be concise. 0.65. What is the ratio of the Debt(current US$) of Uganda in 1986 to that in 1991?
Your answer should be very brief. 0.39. What is the ratio of the Debt(current US$) in Bulgaria in 1987 to that in 1988?
Provide a succinct answer. 4.83. What is the ratio of the Debt(current US$) of Dominica in 1987 to that in 1988?
Provide a succinct answer. 1.06. What is the ratio of the Debt(current US$) in Syrian Arab Republic in 1987 to that in 1988?
Offer a very short reply. 1.23. What is the ratio of the Debt(current US$) in Uganda in 1987 to that in 1988?
Make the answer very short. 0.79. What is the ratio of the Debt(current US$) of Bulgaria in 1987 to that in 1989?
Your response must be concise. 8.39. What is the ratio of the Debt(current US$) of Dominica in 1987 to that in 1989?
Offer a terse response. 1.14. What is the ratio of the Debt(current US$) in Syrian Arab Republic in 1987 to that in 1989?
Provide a short and direct response. 2.18. What is the ratio of the Debt(current US$) in Uganda in 1987 to that in 1989?
Your answer should be very brief. 0.76. What is the ratio of the Debt(current US$) of Bulgaria in 1987 to that in 1990?
Make the answer very short. 16.76. What is the ratio of the Debt(current US$) in Dominica in 1987 to that in 1990?
Provide a short and direct response. 1.41. What is the ratio of the Debt(current US$) in Syrian Arab Republic in 1987 to that in 1990?
Your answer should be compact. 1.49. What is the ratio of the Debt(current US$) of Uganda in 1987 to that in 1990?
Provide a short and direct response. 0.59. What is the ratio of the Debt(current US$) in Bulgaria in 1987 to that in 1991?
Keep it short and to the point. 1.87. What is the ratio of the Debt(current US$) of Dominica in 1987 to that in 1991?
Make the answer very short. 1.49. What is the ratio of the Debt(current US$) of Syrian Arab Republic in 1987 to that in 1991?
Your answer should be very brief. 0.84. What is the ratio of the Debt(current US$) in Uganda in 1987 to that in 1991?
Your answer should be compact. 0.48. What is the ratio of the Debt(current US$) in Bulgaria in 1988 to that in 1989?
Provide a short and direct response. 1.74. What is the ratio of the Debt(current US$) in Dominica in 1988 to that in 1989?
Make the answer very short. 1.08. What is the ratio of the Debt(current US$) of Syrian Arab Republic in 1988 to that in 1989?
Keep it short and to the point. 1.78. What is the ratio of the Debt(current US$) in Uganda in 1988 to that in 1989?
Provide a short and direct response. 0.97. What is the ratio of the Debt(current US$) of Bulgaria in 1988 to that in 1990?
Make the answer very short. 3.47. What is the ratio of the Debt(current US$) in Dominica in 1988 to that in 1990?
Give a very brief answer. 1.34. What is the ratio of the Debt(current US$) in Syrian Arab Republic in 1988 to that in 1990?
Provide a succinct answer. 1.21. What is the ratio of the Debt(current US$) in Uganda in 1988 to that in 1990?
Your answer should be very brief. 0.75. What is the ratio of the Debt(current US$) of Bulgaria in 1988 to that in 1991?
Offer a very short reply. 0.39. What is the ratio of the Debt(current US$) of Dominica in 1988 to that in 1991?
Your answer should be compact. 1.41. What is the ratio of the Debt(current US$) in Syrian Arab Republic in 1988 to that in 1991?
Your answer should be very brief. 0.68. What is the ratio of the Debt(current US$) in Uganda in 1988 to that in 1991?
Offer a very short reply. 0.61. What is the ratio of the Debt(current US$) of Bulgaria in 1989 to that in 1990?
Offer a terse response. 2. What is the ratio of the Debt(current US$) of Dominica in 1989 to that in 1990?
Keep it short and to the point. 1.24. What is the ratio of the Debt(current US$) in Syrian Arab Republic in 1989 to that in 1990?
Your response must be concise. 0.68. What is the ratio of the Debt(current US$) of Uganda in 1989 to that in 1990?
Offer a very short reply. 0.77. What is the ratio of the Debt(current US$) of Bulgaria in 1989 to that in 1991?
Make the answer very short. 0.22. What is the ratio of the Debt(current US$) of Dominica in 1989 to that in 1991?
Ensure brevity in your answer.  1.31. What is the ratio of the Debt(current US$) of Syrian Arab Republic in 1989 to that in 1991?
Ensure brevity in your answer.  0.38. What is the ratio of the Debt(current US$) of Uganda in 1989 to that in 1991?
Make the answer very short. 0.63. What is the ratio of the Debt(current US$) in Bulgaria in 1990 to that in 1991?
Give a very brief answer. 0.11. What is the ratio of the Debt(current US$) in Dominica in 1990 to that in 1991?
Offer a terse response. 1.05. What is the ratio of the Debt(current US$) of Syrian Arab Republic in 1990 to that in 1991?
Offer a very short reply. 0.56. What is the ratio of the Debt(current US$) in Uganda in 1990 to that in 1991?
Your answer should be very brief. 0.82. What is the difference between the highest and the second highest Debt(current US$) of Bulgaria?
Make the answer very short. 1.04e+08. What is the difference between the highest and the second highest Debt(current US$) of Dominica?
Make the answer very short. 1.74e+06. What is the difference between the highest and the second highest Debt(current US$) in Syrian Arab Republic?
Your answer should be very brief. 1.93e+08. What is the difference between the highest and the second highest Debt(current US$) of Uganda?
Offer a very short reply. 1.85e+08. What is the difference between the highest and the lowest Debt(current US$) in Bulgaria?
Your response must be concise. 4.94e+08. What is the difference between the highest and the lowest Debt(current US$) in Dominica?
Make the answer very short. 2.63e+07. What is the difference between the highest and the lowest Debt(current US$) of Syrian Arab Republic?
Offer a very short reply. 7.34e+08. What is the difference between the highest and the lowest Debt(current US$) in Uganda?
Your answer should be compact. 6.09e+08. 